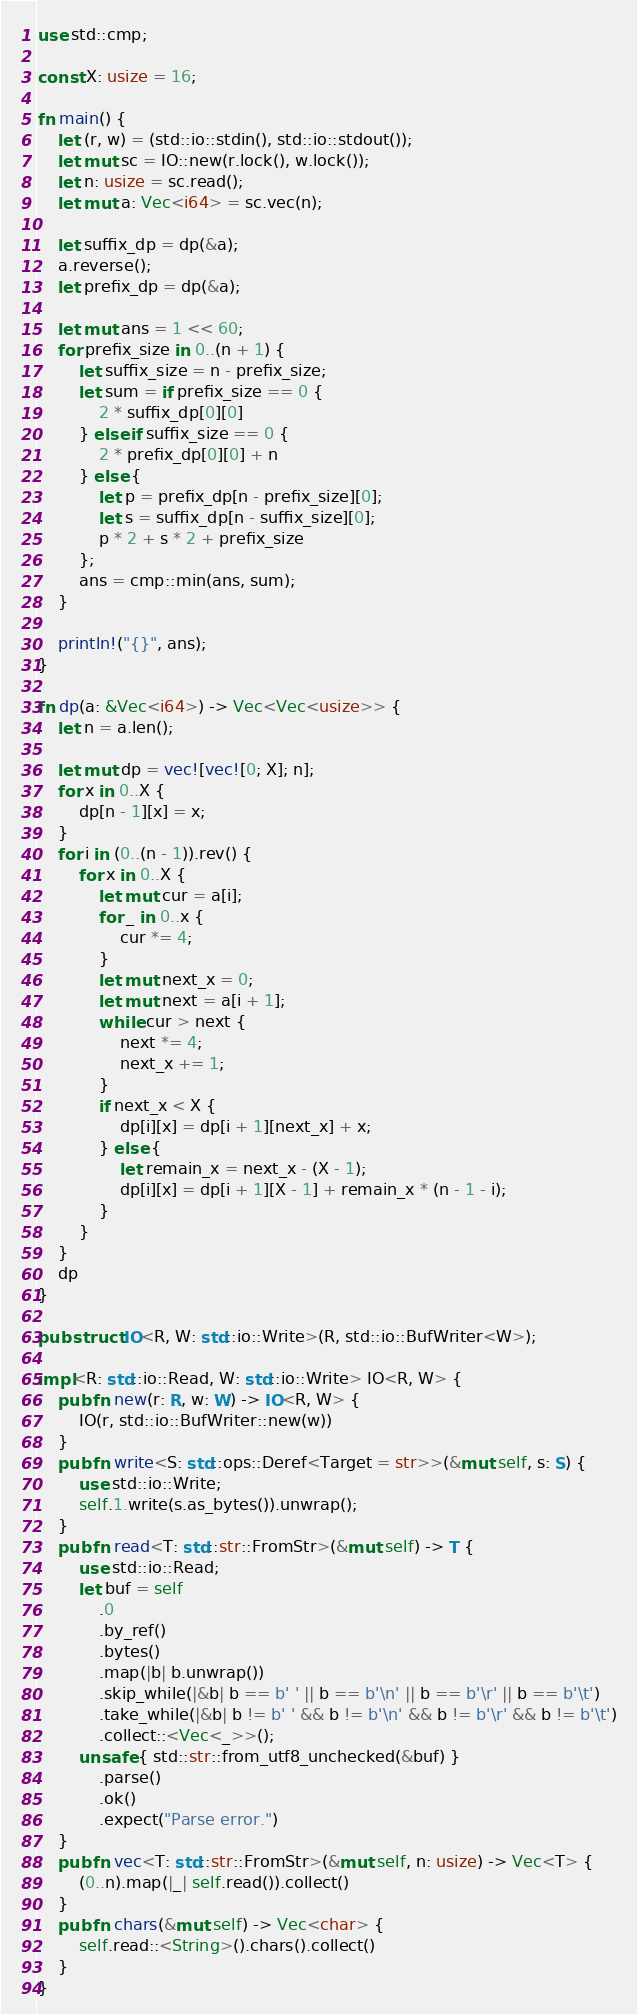<code> <loc_0><loc_0><loc_500><loc_500><_Rust_>use std::cmp;

const X: usize = 16;

fn main() {
    let (r, w) = (std::io::stdin(), std::io::stdout());
    let mut sc = IO::new(r.lock(), w.lock());
    let n: usize = sc.read();
    let mut a: Vec<i64> = sc.vec(n);

    let suffix_dp = dp(&a);
    a.reverse();
    let prefix_dp = dp(&a);

    let mut ans = 1 << 60;
    for prefix_size in 0..(n + 1) {
        let suffix_size = n - prefix_size;
        let sum = if prefix_size == 0 {
            2 * suffix_dp[0][0]
        } else if suffix_size == 0 {
            2 * prefix_dp[0][0] + n
        } else {
            let p = prefix_dp[n - prefix_size][0];
            let s = suffix_dp[n - suffix_size][0];
            p * 2 + s * 2 + prefix_size
        };
        ans = cmp::min(ans, sum);
    }

    println!("{}", ans);
}

fn dp(a: &Vec<i64>) -> Vec<Vec<usize>> {
    let n = a.len();

    let mut dp = vec![vec![0; X]; n];
    for x in 0..X {
        dp[n - 1][x] = x;
    }
    for i in (0..(n - 1)).rev() {
        for x in 0..X {
            let mut cur = a[i];
            for _ in 0..x {
                cur *= 4;
            }
            let mut next_x = 0;
            let mut next = a[i + 1];
            while cur > next {
                next *= 4;
                next_x += 1;
            }
            if next_x < X {
                dp[i][x] = dp[i + 1][next_x] + x;
            } else {
                let remain_x = next_x - (X - 1);
                dp[i][x] = dp[i + 1][X - 1] + remain_x * (n - 1 - i);
            }
        }
    }
    dp
}

pub struct IO<R, W: std::io::Write>(R, std::io::BufWriter<W>);

impl<R: std::io::Read, W: std::io::Write> IO<R, W> {
    pub fn new(r: R, w: W) -> IO<R, W> {
        IO(r, std::io::BufWriter::new(w))
    }
    pub fn write<S: std::ops::Deref<Target = str>>(&mut self, s: S) {
        use std::io::Write;
        self.1.write(s.as_bytes()).unwrap();
    }
    pub fn read<T: std::str::FromStr>(&mut self) -> T {
        use std::io::Read;
        let buf = self
            .0
            .by_ref()
            .bytes()
            .map(|b| b.unwrap())
            .skip_while(|&b| b == b' ' || b == b'\n' || b == b'\r' || b == b'\t')
            .take_while(|&b| b != b' ' && b != b'\n' && b != b'\r' && b != b'\t')
            .collect::<Vec<_>>();
        unsafe { std::str::from_utf8_unchecked(&buf) }
            .parse()
            .ok()
            .expect("Parse error.")
    }
    pub fn vec<T: std::str::FromStr>(&mut self, n: usize) -> Vec<T> {
        (0..n).map(|_| self.read()).collect()
    }
    pub fn chars(&mut self) -> Vec<char> {
        self.read::<String>().chars().collect()
    }
}
</code> 